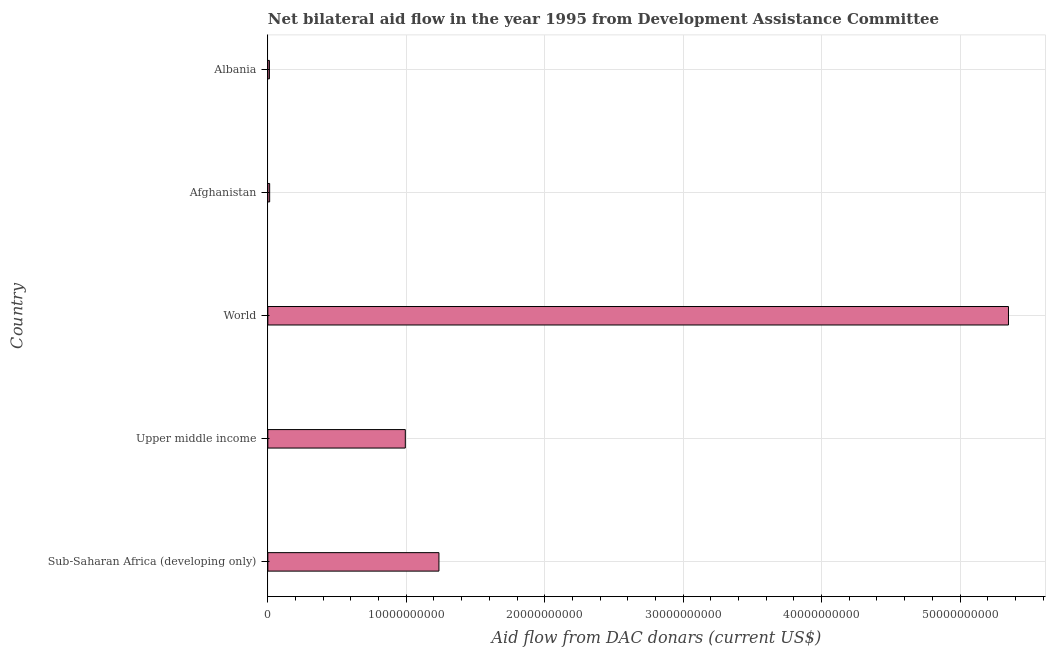What is the title of the graph?
Make the answer very short. Net bilateral aid flow in the year 1995 from Development Assistance Committee. What is the label or title of the X-axis?
Your response must be concise. Aid flow from DAC donars (current US$). What is the label or title of the Y-axis?
Give a very brief answer. Country. What is the net bilateral aid flows from dac donors in Albania?
Ensure brevity in your answer.  1.13e+08. Across all countries, what is the maximum net bilateral aid flows from dac donors?
Your answer should be very brief. 5.35e+1. Across all countries, what is the minimum net bilateral aid flows from dac donors?
Offer a terse response. 1.13e+08. In which country was the net bilateral aid flows from dac donors maximum?
Ensure brevity in your answer.  World. In which country was the net bilateral aid flows from dac donors minimum?
Ensure brevity in your answer.  Albania. What is the sum of the net bilateral aid flows from dac donors?
Give a very brief answer. 7.60e+1. What is the difference between the net bilateral aid flows from dac donors in Afghanistan and Upper middle income?
Your response must be concise. -9.80e+09. What is the average net bilateral aid flows from dac donors per country?
Provide a succinct answer. 1.52e+1. What is the median net bilateral aid flows from dac donors?
Your answer should be very brief. 9.93e+09. In how many countries, is the net bilateral aid flows from dac donors greater than 42000000000 US$?
Provide a succinct answer. 1. What is the ratio of the net bilateral aid flows from dac donors in Afghanistan to that in Sub-Saharan Africa (developing only)?
Ensure brevity in your answer.  0.01. Is the difference between the net bilateral aid flows from dac donors in Sub-Saharan Africa (developing only) and World greater than the difference between any two countries?
Make the answer very short. No. What is the difference between the highest and the second highest net bilateral aid flows from dac donors?
Keep it short and to the point. 4.11e+1. Is the sum of the net bilateral aid flows from dac donors in Afghanistan and Sub-Saharan Africa (developing only) greater than the maximum net bilateral aid flows from dac donors across all countries?
Your answer should be compact. No. What is the difference between the highest and the lowest net bilateral aid flows from dac donors?
Offer a very short reply. 5.34e+1. In how many countries, is the net bilateral aid flows from dac donors greater than the average net bilateral aid flows from dac donors taken over all countries?
Your answer should be compact. 1. What is the difference between two consecutive major ticks on the X-axis?
Your answer should be compact. 1.00e+1. What is the Aid flow from DAC donars (current US$) in Sub-Saharan Africa (developing only)?
Your answer should be very brief. 1.24e+1. What is the Aid flow from DAC donars (current US$) in Upper middle income?
Your response must be concise. 9.93e+09. What is the Aid flow from DAC donars (current US$) of World?
Provide a short and direct response. 5.35e+1. What is the Aid flow from DAC donars (current US$) in Afghanistan?
Your answer should be very brief. 1.31e+08. What is the Aid flow from DAC donars (current US$) of Albania?
Offer a very short reply. 1.13e+08. What is the difference between the Aid flow from DAC donars (current US$) in Sub-Saharan Africa (developing only) and Upper middle income?
Keep it short and to the point. 2.43e+09. What is the difference between the Aid flow from DAC donars (current US$) in Sub-Saharan Africa (developing only) and World?
Give a very brief answer. -4.11e+1. What is the difference between the Aid flow from DAC donars (current US$) in Sub-Saharan Africa (developing only) and Afghanistan?
Provide a succinct answer. 1.22e+1. What is the difference between the Aid flow from DAC donars (current US$) in Sub-Saharan Africa (developing only) and Albania?
Your response must be concise. 1.22e+1. What is the difference between the Aid flow from DAC donars (current US$) in Upper middle income and World?
Offer a very short reply. -4.36e+1. What is the difference between the Aid flow from DAC donars (current US$) in Upper middle income and Afghanistan?
Offer a very short reply. 9.80e+09. What is the difference between the Aid flow from DAC donars (current US$) in Upper middle income and Albania?
Provide a short and direct response. 9.82e+09. What is the difference between the Aid flow from DAC donars (current US$) in World and Afghanistan?
Provide a short and direct response. 5.34e+1. What is the difference between the Aid flow from DAC donars (current US$) in World and Albania?
Provide a short and direct response. 5.34e+1. What is the difference between the Aid flow from DAC donars (current US$) in Afghanistan and Albania?
Your answer should be compact. 1.74e+07. What is the ratio of the Aid flow from DAC donars (current US$) in Sub-Saharan Africa (developing only) to that in Upper middle income?
Provide a succinct answer. 1.25. What is the ratio of the Aid flow from DAC donars (current US$) in Sub-Saharan Africa (developing only) to that in World?
Provide a succinct answer. 0.23. What is the ratio of the Aid flow from DAC donars (current US$) in Sub-Saharan Africa (developing only) to that in Afghanistan?
Make the answer very short. 94.63. What is the ratio of the Aid flow from DAC donars (current US$) in Sub-Saharan Africa (developing only) to that in Albania?
Your response must be concise. 109.18. What is the ratio of the Aid flow from DAC donars (current US$) in Upper middle income to that in World?
Your answer should be compact. 0.19. What is the ratio of the Aid flow from DAC donars (current US$) in Upper middle income to that in Afghanistan?
Your answer should be compact. 76.03. What is the ratio of the Aid flow from DAC donars (current US$) in Upper middle income to that in Albania?
Offer a very short reply. 87.72. What is the ratio of the Aid flow from DAC donars (current US$) in World to that in Afghanistan?
Offer a very short reply. 409.61. What is the ratio of the Aid flow from DAC donars (current US$) in World to that in Albania?
Give a very brief answer. 472.61. What is the ratio of the Aid flow from DAC donars (current US$) in Afghanistan to that in Albania?
Ensure brevity in your answer.  1.15. 